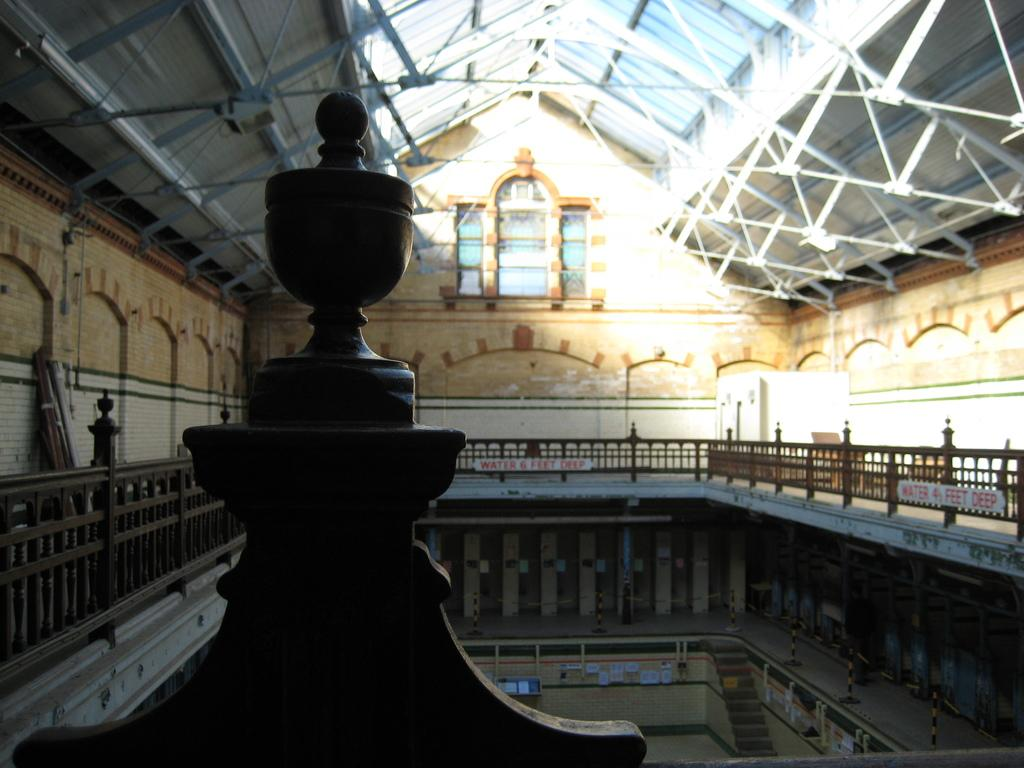Where was the image taken? The image was taken inside a building. What can be seen in the center of the image? There are railings in the center of the image. What is visible in the background of the image? There is a window in the background of the image. What is visible at the top of the image? There is a roof visible at the top of the image. How many toys can be seen on the floor in the image? There are no toys visible in the image. What type of minute detail can be observed in the image? The image does not contain any minute details that can be observed. 